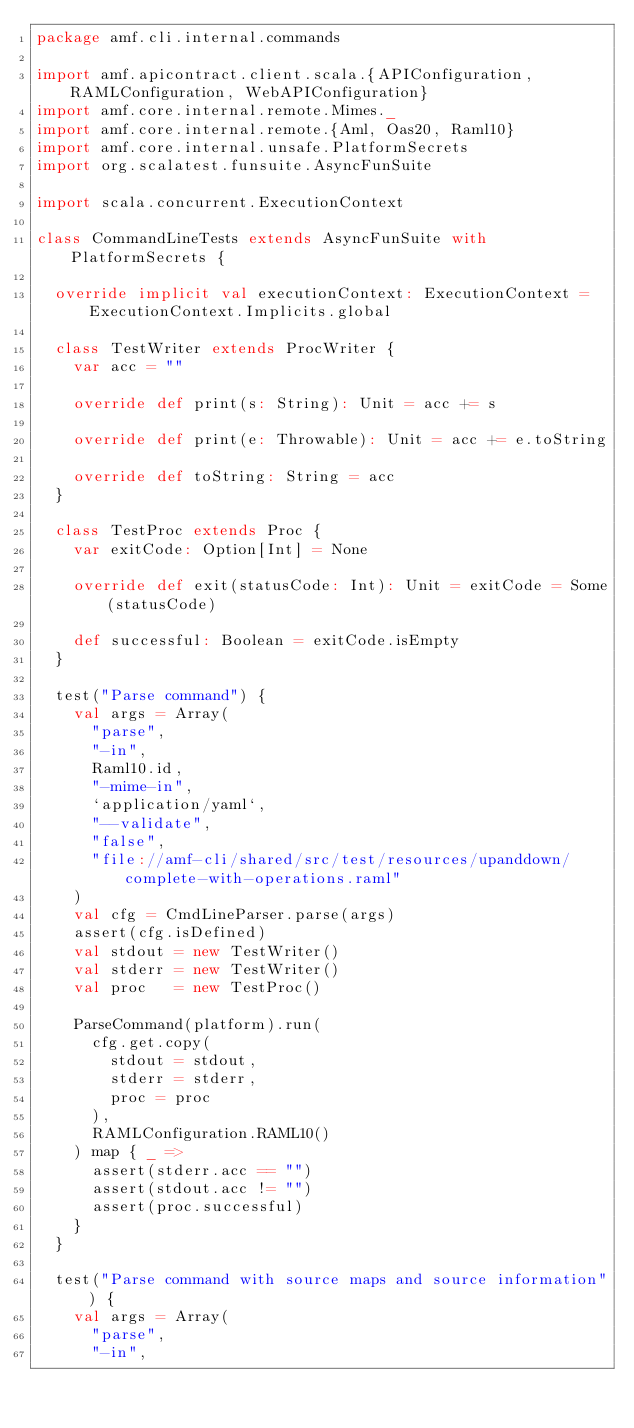Convert code to text. <code><loc_0><loc_0><loc_500><loc_500><_Scala_>package amf.cli.internal.commands

import amf.apicontract.client.scala.{APIConfiguration, RAMLConfiguration, WebAPIConfiguration}
import amf.core.internal.remote.Mimes._
import amf.core.internal.remote.{Aml, Oas20, Raml10}
import amf.core.internal.unsafe.PlatformSecrets
import org.scalatest.funsuite.AsyncFunSuite

import scala.concurrent.ExecutionContext

class CommandLineTests extends AsyncFunSuite with PlatformSecrets {

  override implicit val executionContext: ExecutionContext = ExecutionContext.Implicits.global

  class TestWriter extends ProcWriter {
    var acc = ""

    override def print(s: String): Unit = acc += s

    override def print(e: Throwable): Unit = acc += e.toString

    override def toString: String = acc
  }

  class TestProc extends Proc {
    var exitCode: Option[Int] = None

    override def exit(statusCode: Int): Unit = exitCode = Some(statusCode)

    def successful: Boolean = exitCode.isEmpty
  }

  test("Parse command") {
    val args = Array(
      "parse",
      "-in",
      Raml10.id,
      "-mime-in",
      `application/yaml`,
      "--validate",
      "false",
      "file://amf-cli/shared/src/test/resources/upanddown/complete-with-operations.raml"
    )
    val cfg = CmdLineParser.parse(args)
    assert(cfg.isDefined)
    val stdout = new TestWriter()
    val stderr = new TestWriter()
    val proc   = new TestProc()

    ParseCommand(platform).run(
      cfg.get.copy(
        stdout = stdout,
        stderr = stderr,
        proc = proc
      ),
      RAMLConfiguration.RAML10()
    ) map { _ =>
      assert(stderr.acc == "")
      assert(stdout.acc != "")
      assert(proc.successful)
    }
  }

  test("Parse command with source maps and source information") {
    val args = Array(
      "parse",
      "-in",</code> 